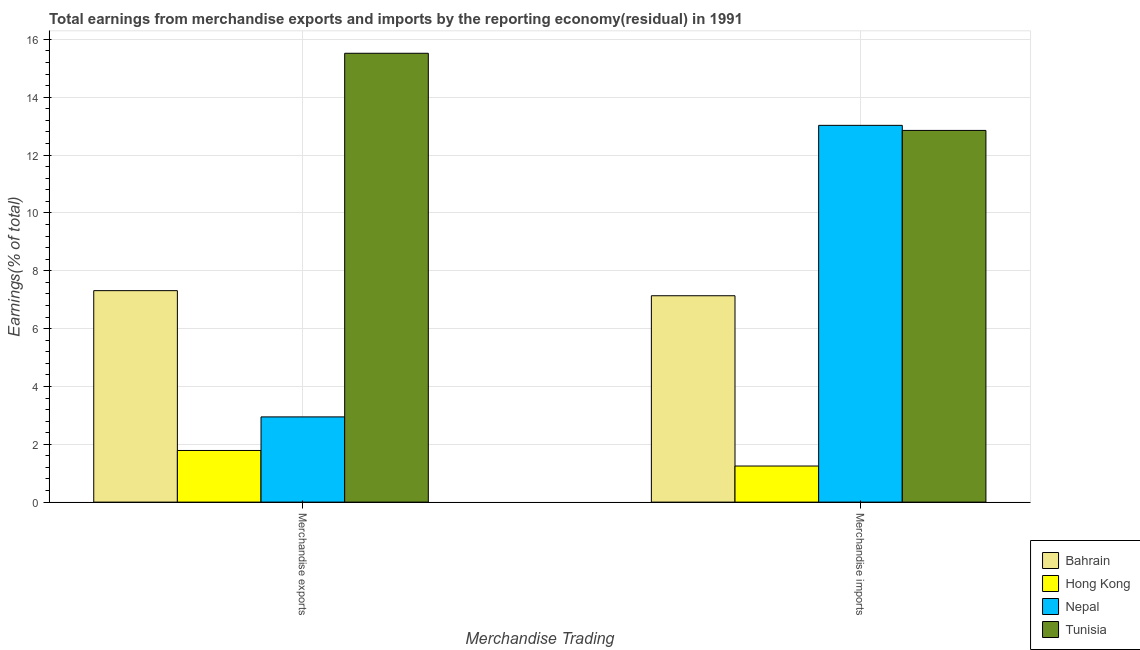How many different coloured bars are there?
Offer a very short reply. 4. How many groups of bars are there?
Your answer should be very brief. 2. Are the number of bars per tick equal to the number of legend labels?
Keep it short and to the point. Yes. How many bars are there on the 2nd tick from the left?
Ensure brevity in your answer.  4. What is the earnings from merchandise imports in Tunisia?
Offer a terse response. 12.85. Across all countries, what is the maximum earnings from merchandise imports?
Give a very brief answer. 13.03. Across all countries, what is the minimum earnings from merchandise exports?
Keep it short and to the point. 1.79. In which country was the earnings from merchandise exports maximum?
Make the answer very short. Tunisia. In which country was the earnings from merchandise imports minimum?
Your answer should be compact. Hong Kong. What is the total earnings from merchandise imports in the graph?
Offer a terse response. 34.26. What is the difference between the earnings from merchandise exports in Hong Kong and that in Nepal?
Your answer should be compact. -1.16. What is the difference between the earnings from merchandise imports in Bahrain and the earnings from merchandise exports in Tunisia?
Provide a short and direct response. -8.38. What is the average earnings from merchandise imports per country?
Make the answer very short. 8.57. What is the difference between the earnings from merchandise imports and earnings from merchandise exports in Tunisia?
Offer a very short reply. -2.67. In how many countries, is the earnings from merchandise imports greater than 15.2 %?
Provide a short and direct response. 0. What is the ratio of the earnings from merchandise exports in Hong Kong to that in Bahrain?
Give a very brief answer. 0.24. What does the 3rd bar from the left in Merchandise imports represents?
Offer a very short reply. Nepal. What does the 2nd bar from the right in Merchandise imports represents?
Your answer should be compact. Nepal. How many bars are there?
Keep it short and to the point. 8. Are all the bars in the graph horizontal?
Ensure brevity in your answer.  No. What is the difference between two consecutive major ticks on the Y-axis?
Ensure brevity in your answer.  2. Where does the legend appear in the graph?
Provide a succinct answer. Bottom right. How are the legend labels stacked?
Your answer should be compact. Vertical. What is the title of the graph?
Provide a short and direct response. Total earnings from merchandise exports and imports by the reporting economy(residual) in 1991. What is the label or title of the X-axis?
Keep it short and to the point. Merchandise Trading. What is the label or title of the Y-axis?
Ensure brevity in your answer.  Earnings(% of total). What is the Earnings(% of total) in Bahrain in Merchandise exports?
Offer a very short reply. 7.31. What is the Earnings(% of total) in Hong Kong in Merchandise exports?
Your answer should be compact. 1.79. What is the Earnings(% of total) in Nepal in Merchandise exports?
Offer a very short reply. 2.95. What is the Earnings(% of total) of Tunisia in Merchandise exports?
Your answer should be compact. 15.52. What is the Earnings(% of total) in Bahrain in Merchandise imports?
Ensure brevity in your answer.  7.14. What is the Earnings(% of total) of Hong Kong in Merchandise imports?
Provide a succinct answer. 1.25. What is the Earnings(% of total) in Nepal in Merchandise imports?
Give a very brief answer. 13.03. What is the Earnings(% of total) of Tunisia in Merchandise imports?
Provide a succinct answer. 12.85. Across all Merchandise Trading, what is the maximum Earnings(% of total) in Bahrain?
Your response must be concise. 7.31. Across all Merchandise Trading, what is the maximum Earnings(% of total) of Hong Kong?
Your answer should be compact. 1.79. Across all Merchandise Trading, what is the maximum Earnings(% of total) of Nepal?
Provide a short and direct response. 13.03. Across all Merchandise Trading, what is the maximum Earnings(% of total) of Tunisia?
Offer a very short reply. 15.52. Across all Merchandise Trading, what is the minimum Earnings(% of total) in Bahrain?
Keep it short and to the point. 7.14. Across all Merchandise Trading, what is the minimum Earnings(% of total) of Hong Kong?
Provide a succinct answer. 1.25. Across all Merchandise Trading, what is the minimum Earnings(% of total) of Nepal?
Ensure brevity in your answer.  2.95. Across all Merchandise Trading, what is the minimum Earnings(% of total) of Tunisia?
Give a very brief answer. 12.85. What is the total Earnings(% of total) in Bahrain in the graph?
Offer a terse response. 14.45. What is the total Earnings(% of total) of Hong Kong in the graph?
Keep it short and to the point. 3.03. What is the total Earnings(% of total) of Nepal in the graph?
Your answer should be compact. 15.97. What is the total Earnings(% of total) in Tunisia in the graph?
Offer a terse response. 28.37. What is the difference between the Earnings(% of total) in Bahrain in Merchandise exports and that in Merchandise imports?
Give a very brief answer. 0.18. What is the difference between the Earnings(% of total) in Hong Kong in Merchandise exports and that in Merchandise imports?
Your answer should be compact. 0.54. What is the difference between the Earnings(% of total) in Nepal in Merchandise exports and that in Merchandise imports?
Provide a succinct answer. -10.08. What is the difference between the Earnings(% of total) in Tunisia in Merchandise exports and that in Merchandise imports?
Your response must be concise. 2.67. What is the difference between the Earnings(% of total) in Bahrain in Merchandise exports and the Earnings(% of total) in Hong Kong in Merchandise imports?
Offer a terse response. 6.06. What is the difference between the Earnings(% of total) of Bahrain in Merchandise exports and the Earnings(% of total) of Nepal in Merchandise imports?
Make the answer very short. -5.72. What is the difference between the Earnings(% of total) of Bahrain in Merchandise exports and the Earnings(% of total) of Tunisia in Merchandise imports?
Your response must be concise. -5.54. What is the difference between the Earnings(% of total) in Hong Kong in Merchandise exports and the Earnings(% of total) in Nepal in Merchandise imports?
Your answer should be very brief. -11.24. What is the difference between the Earnings(% of total) in Hong Kong in Merchandise exports and the Earnings(% of total) in Tunisia in Merchandise imports?
Make the answer very short. -11.07. What is the difference between the Earnings(% of total) of Nepal in Merchandise exports and the Earnings(% of total) of Tunisia in Merchandise imports?
Your answer should be compact. -9.91. What is the average Earnings(% of total) of Bahrain per Merchandise Trading?
Provide a short and direct response. 7.22. What is the average Earnings(% of total) in Hong Kong per Merchandise Trading?
Provide a short and direct response. 1.52. What is the average Earnings(% of total) of Nepal per Merchandise Trading?
Offer a terse response. 7.99. What is the average Earnings(% of total) in Tunisia per Merchandise Trading?
Keep it short and to the point. 14.19. What is the difference between the Earnings(% of total) of Bahrain and Earnings(% of total) of Hong Kong in Merchandise exports?
Make the answer very short. 5.53. What is the difference between the Earnings(% of total) of Bahrain and Earnings(% of total) of Nepal in Merchandise exports?
Your answer should be compact. 4.37. What is the difference between the Earnings(% of total) of Bahrain and Earnings(% of total) of Tunisia in Merchandise exports?
Offer a very short reply. -8.21. What is the difference between the Earnings(% of total) of Hong Kong and Earnings(% of total) of Nepal in Merchandise exports?
Keep it short and to the point. -1.16. What is the difference between the Earnings(% of total) in Hong Kong and Earnings(% of total) in Tunisia in Merchandise exports?
Offer a terse response. -13.73. What is the difference between the Earnings(% of total) of Nepal and Earnings(% of total) of Tunisia in Merchandise exports?
Keep it short and to the point. -12.57. What is the difference between the Earnings(% of total) in Bahrain and Earnings(% of total) in Hong Kong in Merchandise imports?
Your answer should be compact. 5.89. What is the difference between the Earnings(% of total) in Bahrain and Earnings(% of total) in Nepal in Merchandise imports?
Your answer should be very brief. -5.89. What is the difference between the Earnings(% of total) in Bahrain and Earnings(% of total) in Tunisia in Merchandise imports?
Make the answer very short. -5.72. What is the difference between the Earnings(% of total) in Hong Kong and Earnings(% of total) in Nepal in Merchandise imports?
Offer a terse response. -11.78. What is the difference between the Earnings(% of total) in Hong Kong and Earnings(% of total) in Tunisia in Merchandise imports?
Your answer should be very brief. -11.6. What is the difference between the Earnings(% of total) of Nepal and Earnings(% of total) of Tunisia in Merchandise imports?
Keep it short and to the point. 0.18. What is the ratio of the Earnings(% of total) of Bahrain in Merchandise exports to that in Merchandise imports?
Ensure brevity in your answer.  1.02. What is the ratio of the Earnings(% of total) of Hong Kong in Merchandise exports to that in Merchandise imports?
Ensure brevity in your answer.  1.43. What is the ratio of the Earnings(% of total) of Nepal in Merchandise exports to that in Merchandise imports?
Give a very brief answer. 0.23. What is the ratio of the Earnings(% of total) of Tunisia in Merchandise exports to that in Merchandise imports?
Your response must be concise. 1.21. What is the difference between the highest and the second highest Earnings(% of total) of Bahrain?
Make the answer very short. 0.18. What is the difference between the highest and the second highest Earnings(% of total) of Hong Kong?
Provide a short and direct response. 0.54. What is the difference between the highest and the second highest Earnings(% of total) of Nepal?
Keep it short and to the point. 10.08. What is the difference between the highest and the second highest Earnings(% of total) of Tunisia?
Offer a very short reply. 2.67. What is the difference between the highest and the lowest Earnings(% of total) of Bahrain?
Your answer should be very brief. 0.18. What is the difference between the highest and the lowest Earnings(% of total) of Hong Kong?
Make the answer very short. 0.54. What is the difference between the highest and the lowest Earnings(% of total) in Nepal?
Keep it short and to the point. 10.08. What is the difference between the highest and the lowest Earnings(% of total) of Tunisia?
Provide a short and direct response. 2.67. 